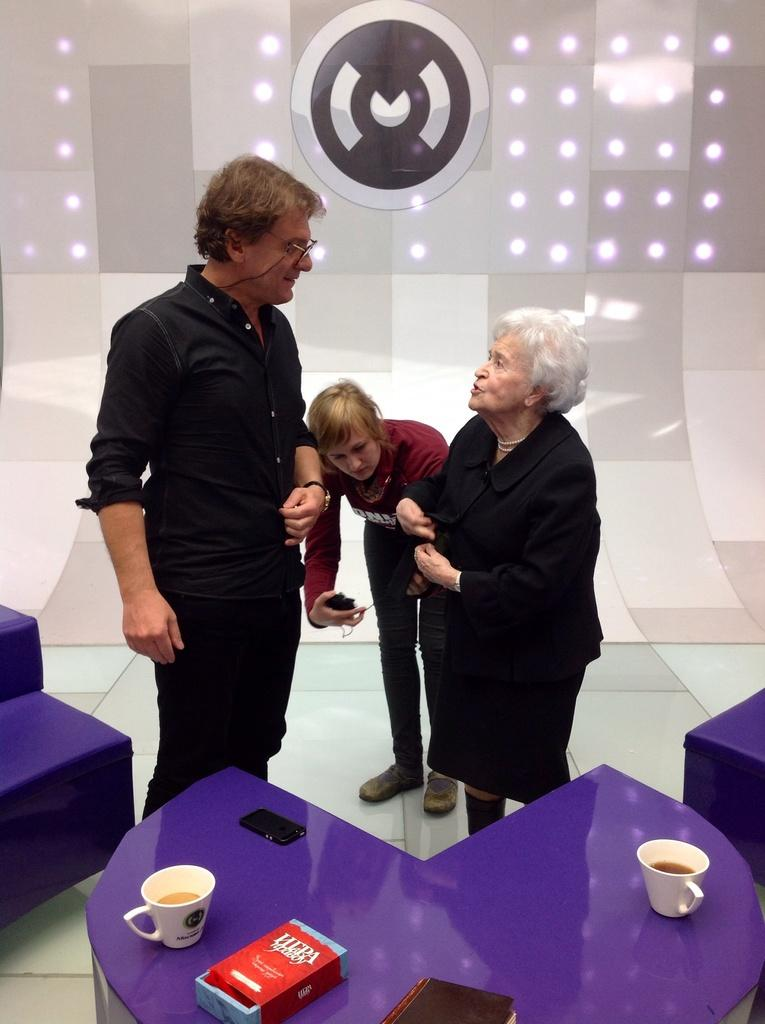What is the gender of the person standing in the image? There is a man standing in the image. What is the man's position in relation to the floor? The man is standing on the floor. What is the gender of the other person in the image? There is a woman standing in the image. What is the woman doing in the image? The woman is talking. Where is the woman standing in relation to the man? The woman is standing opposite the man. What furniture is present in the image? There is a table in the image. What is on the table? There is a tea cup on the table, and there are other objects on the table as well. What is the purpose of the coal in the image? There is no coal present in the image. What activity is the woman engaged in with the other objects on the table? The image does not show the woman interacting with any other objects on the table, so it cannot be determined what activity she might be engaged in with them. 